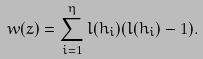<formula> <loc_0><loc_0><loc_500><loc_500>\ w ( z ) = \sum _ { i = 1 } ^ { \eta } l ( h _ { i } ) ( l ( h _ { i } ) - 1 ) .</formula> 